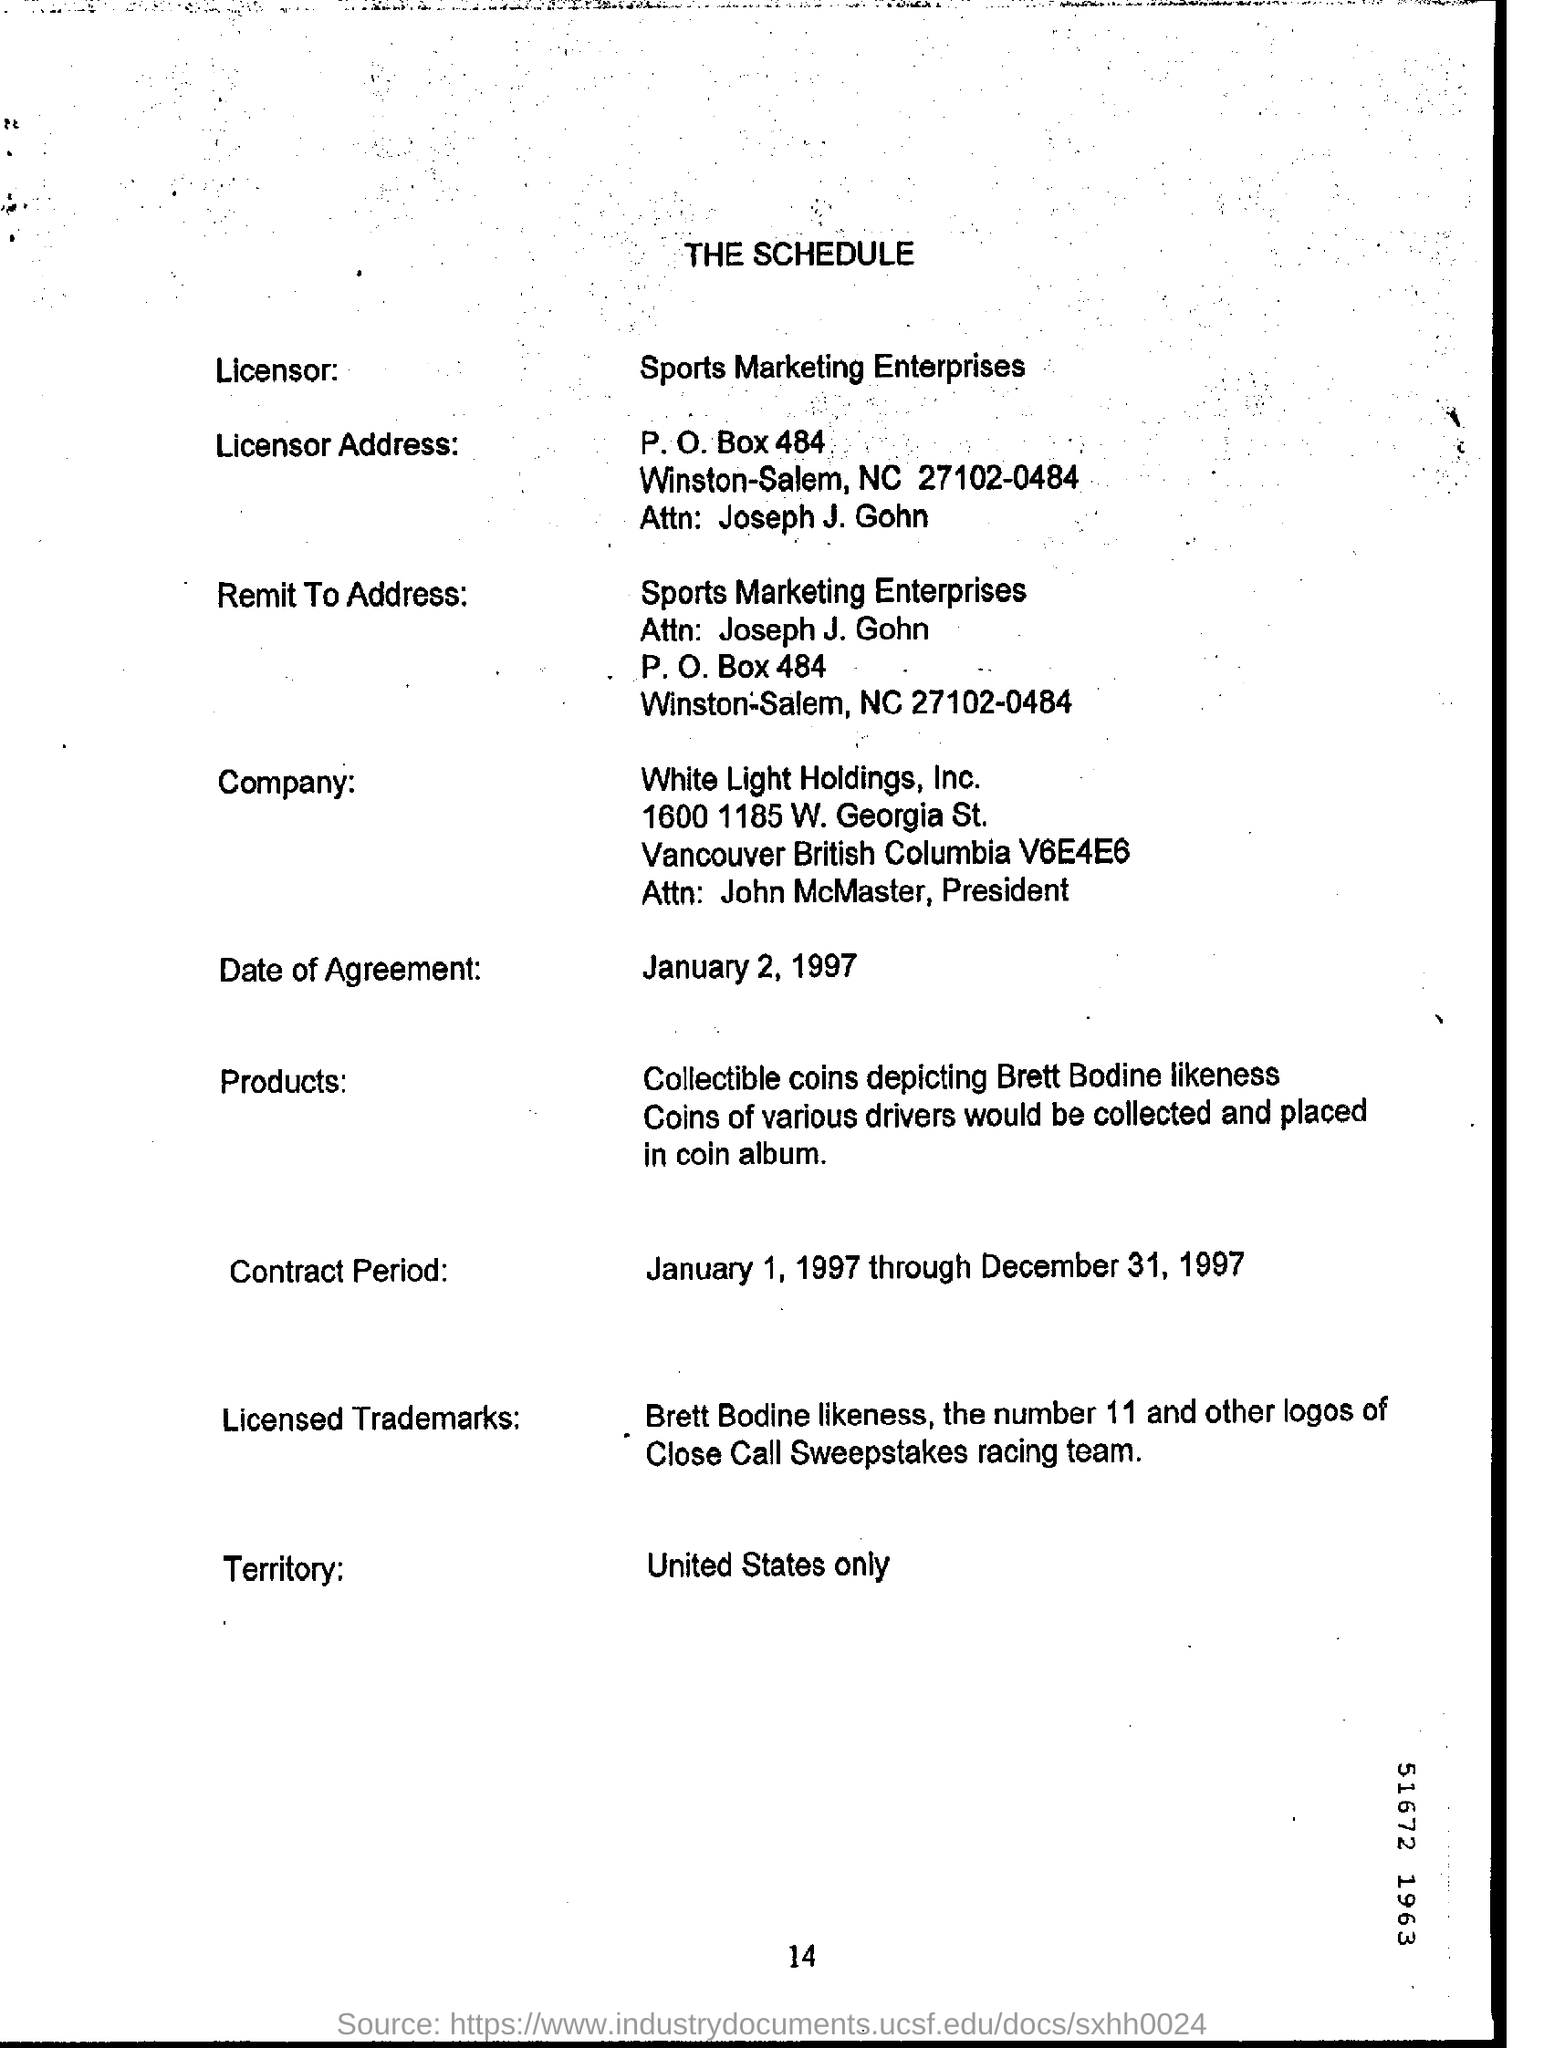Draw attention to some important aspects in this diagram. The title of the document is THE SCHEDULE. The company named White Light Holdings, Inc. has been identified. I am not sure what you are asking for. Could you please provide more context or clarify your request? Sports Marketing Enterprises is the licensor. The date of agreement is January 2, 1997. 